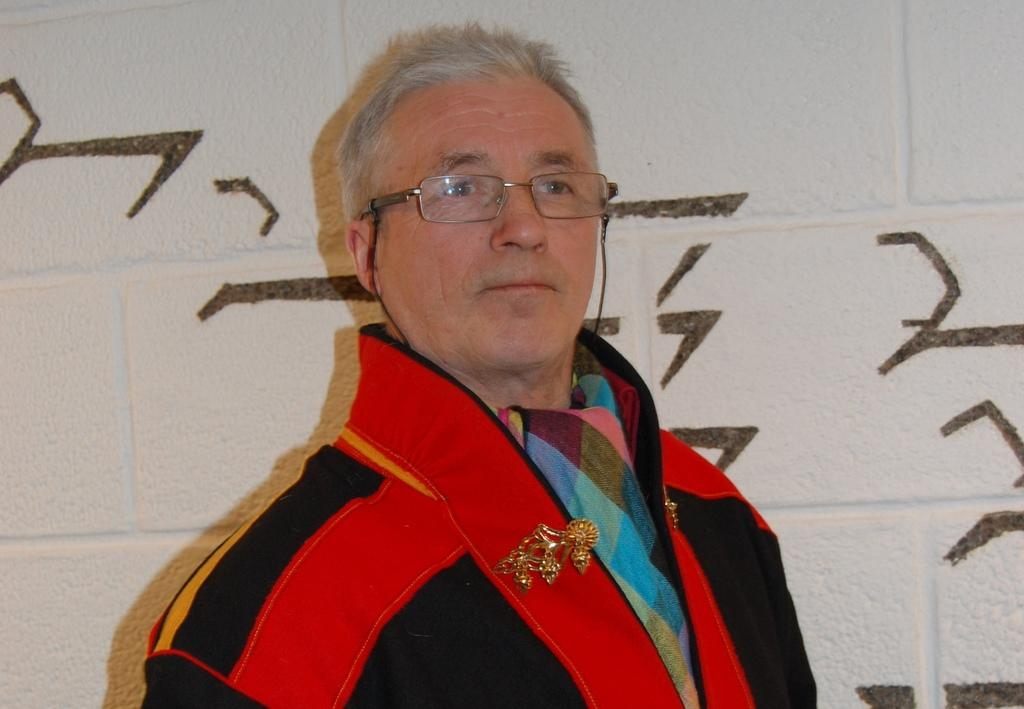Who is present in the image? There is a man in the image. What can be seen on the man's face? The man is wearing spectacles. What is the background of the image? There is a white wall behind the man. What type of coast can be seen in the image? There is no coast visible in the image; it features a man with spectacles in front of a white wall. 